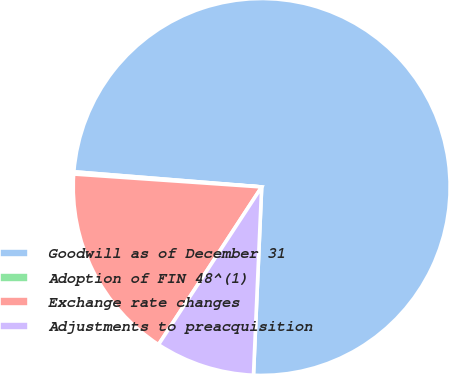Convert chart. <chart><loc_0><loc_0><loc_500><loc_500><pie_chart><fcel>Goodwill as of December 31<fcel>Adoption of FIN 48^(1)<fcel>Exchange rate changes<fcel>Adjustments to preacquisition<nl><fcel>74.41%<fcel>0.19%<fcel>16.87%<fcel>8.53%<nl></chart> 